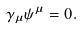Convert formula to latex. <formula><loc_0><loc_0><loc_500><loc_500>\gamma _ { \mu } \psi ^ { \mu } = 0 .</formula> 